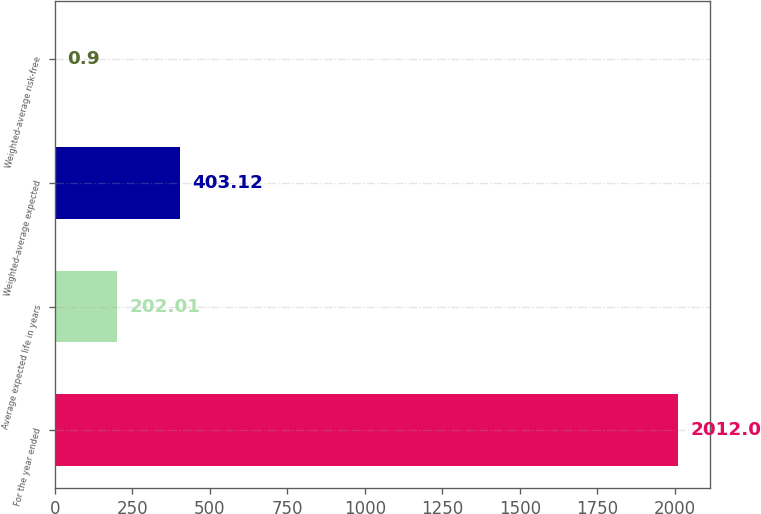Convert chart to OTSL. <chart><loc_0><loc_0><loc_500><loc_500><bar_chart><fcel>For the year ended<fcel>Average expected life in years<fcel>Weighted-average expected<fcel>Weighted-average risk-free<nl><fcel>2012<fcel>202.01<fcel>403.12<fcel>0.9<nl></chart> 